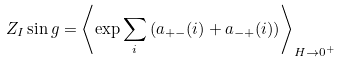<formula> <loc_0><loc_0><loc_500><loc_500>Z _ { I } \sin g = \left \langle \exp \sum _ { i } \left ( a _ { + - } ( i ) + a _ { - + } ( i ) \right ) \right \rangle _ { H \rightarrow 0 ^ { + } }</formula> 